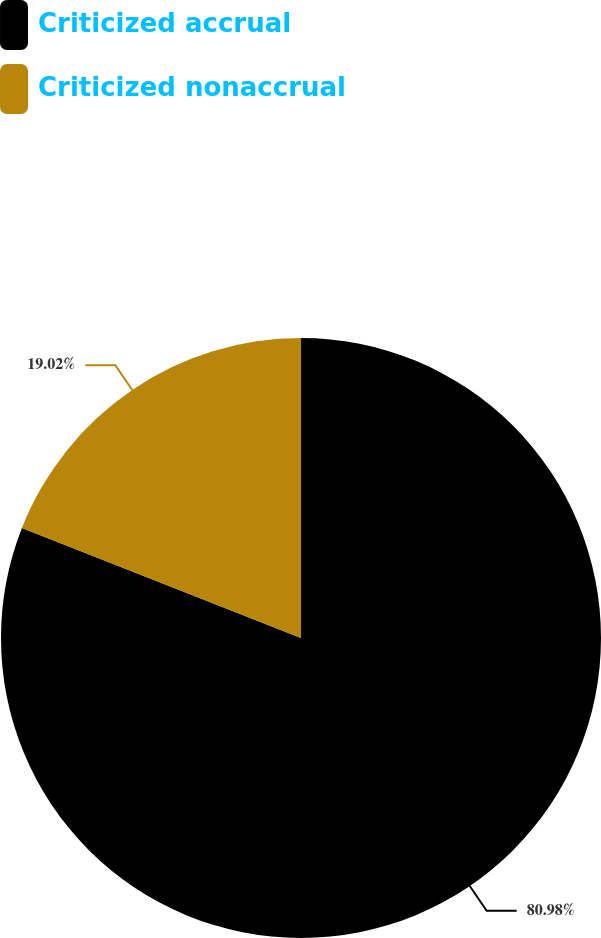Convert chart. <chart><loc_0><loc_0><loc_500><loc_500><pie_chart><fcel>Criticized accrual<fcel>Criticized nonaccrual<nl><fcel>80.98%<fcel>19.02%<nl></chart> 